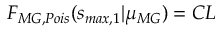<formula> <loc_0><loc_0><loc_500><loc_500>F _ { M G , P o i s } ( s _ { \max , 1 } | \mu _ { M G } ) = C L</formula> 